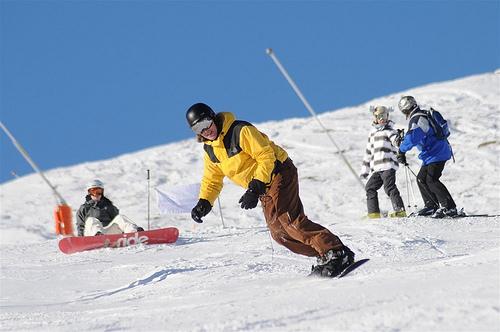What is written on the bottom of the snowboard?
Answer briefly. Ride. What is on the bottom of the red snowboard?
Be succinct. Ride. What color is the sky?
Write a very short answer. Blue. Are all the skiers going in the same direction?
Answer briefly. Yes. What are they doing?
Quick response, please. Skiing. 